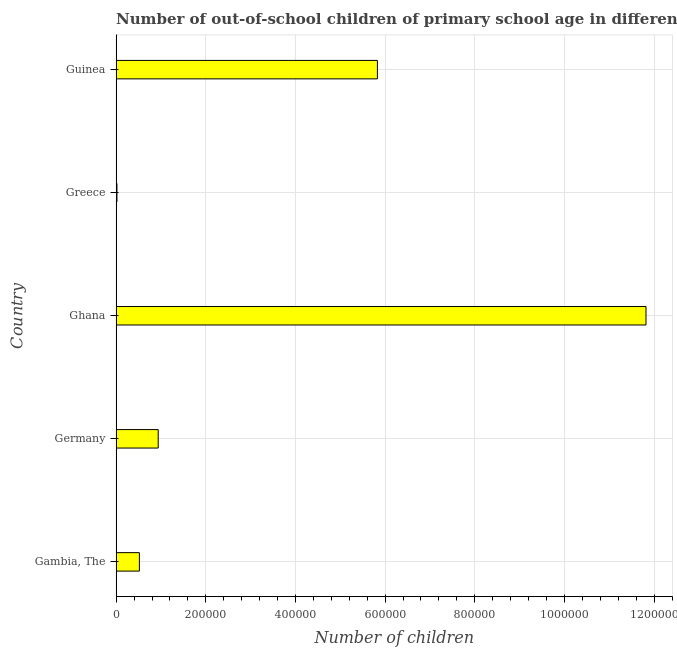Does the graph contain any zero values?
Keep it short and to the point. No. What is the title of the graph?
Provide a short and direct response. Number of out-of-school children of primary school age in different countries. What is the label or title of the X-axis?
Offer a very short reply. Number of children. What is the label or title of the Y-axis?
Provide a short and direct response. Country. What is the number of out-of-school children in Guinea?
Offer a terse response. 5.83e+05. Across all countries, what is the maximum number of out-of-school children?
Ensure brevity in your answer.  1.18e+06. Across all countries, what is the minimum number of out-of-school children?
Make the answer very short. 1832. In which country was the number of out-of-school children maximum?
Your answer should be very brief. Ghana. What is the sum of the number of out-of-school children?
Your answer should be compact. 1.91e+06. What is the difference between the number of out-of-school children in Gambia, The and Ghana?
Your response must be concise. -1.13e+06. What is the average number of out-of-school children per country?
Your answer should be very brief. 3.82e+05. What is the median number of out-of-school children?
Ensure brevity in your answer.  9.39e+04. What is the ratio of the number of out-of-school children in Germany to that in Guinea?
Offer a terse response. 0.16. Is the number of out-of-school children in Gambia, The less than that in Guinea?
Your response must be concise. Yes. What is the difference between the highest and the second highest number of out-of-school children?
Make the answer very short. 5.99e+05. Is the sum of the number of out-of-school children in Gambia, The and Ghana greater than the maximum number of out-of-school children across all countries?
Make the answer very short. Yes. What is the difference between the highest and the lowest number of out-of-school children?
Your answer should be very brief. 1.18e+06. How many bars are there?
Keep it short and to the point. 5. Are all the bars in the graph horizontal?
Ensure brevity in your answer.  Yes. What is the Number of children of Gambia, The?
Your answer should be compact. 5.19e+04. What is the Number of children in Germany?
Offer a terse response. 9.39e+04. What is the Number of children of Ghana?
Provide a succinct answer. 1.18e+06. What is the Number of children of Greece?
Keep it short and to the point. 1832. What is the Number of children in Guinea?
Ensure brevity in your answer.  5.83e+05. What is the difference between the Number of children in Gambia, The and Germany?
Make the answer very short. -4.20e+04. What is the difference between the Number of children in Gambia, The and Ghana?
Your answer should be compact. -1.13e+06. What is the difference between the Number of children in Gambia, The and Greece?
Give a very brief answer. 5.00e+04. What is the difference between the Number of children in Gambia, The and Guinea?
Offer a very short reply. -5.31e+05. What is the difference between the Number of children in Germany and Ghana?
Give a very brief answer. -1.09e+06. What is the difference between the Number of children in Germany and Greece?
Your answer should be compact. 9.20e+04. What is the difference between the Number of children in Germany and Guinea?
Provide a succinct answer. -4.89e+05. What is the difference between the Number of children in Ghana and Greece?
Give a very brief answer. 1.18e+06. What is the difference between the Number of children in Ghana and Guinea?
Provide a succinct answer. 5.99e+05. What is the difference between the Number of children in Greece and Guinea?
Your answer should be compact. -5.81e+05. What is the ratio of the Number of children in Gambia, The to that in Germany?
Your answer should be very brief. 0.55. What is the ratio of the Number of children in Gambia, The to that in Ghana?
Make the answer very short. 0.04. What is the ratio of the Number of children in Gambia, The to that in Greece?
Give a very brief answer. 28.32. What is the ratio of the Number of children in Gambia, The to that in Guinea?
Your answer should be compact. 0.09. What is the ratio of the Number of children in Germany to that in Ghana?
Ensure brevity in your answer.  0.08. What is the ratio of the Number of children in Germany to that in Greece?
Your answer should be compact. 51.23. What is the ratio of the Number of children in Germany to that in Guinea?
Your answer should be compact. 0.16. What is the ratio of the Number of children in Ghana to that in Greece?
Keep it short and to the point. 645.17. What is the ratio of the Number of children in Ghana to that in Guinea?
Give a very brief answer. 2.03. What is the ratio of the Number of children in Greece to that in Guinea?
Make the answer very short. 0. 